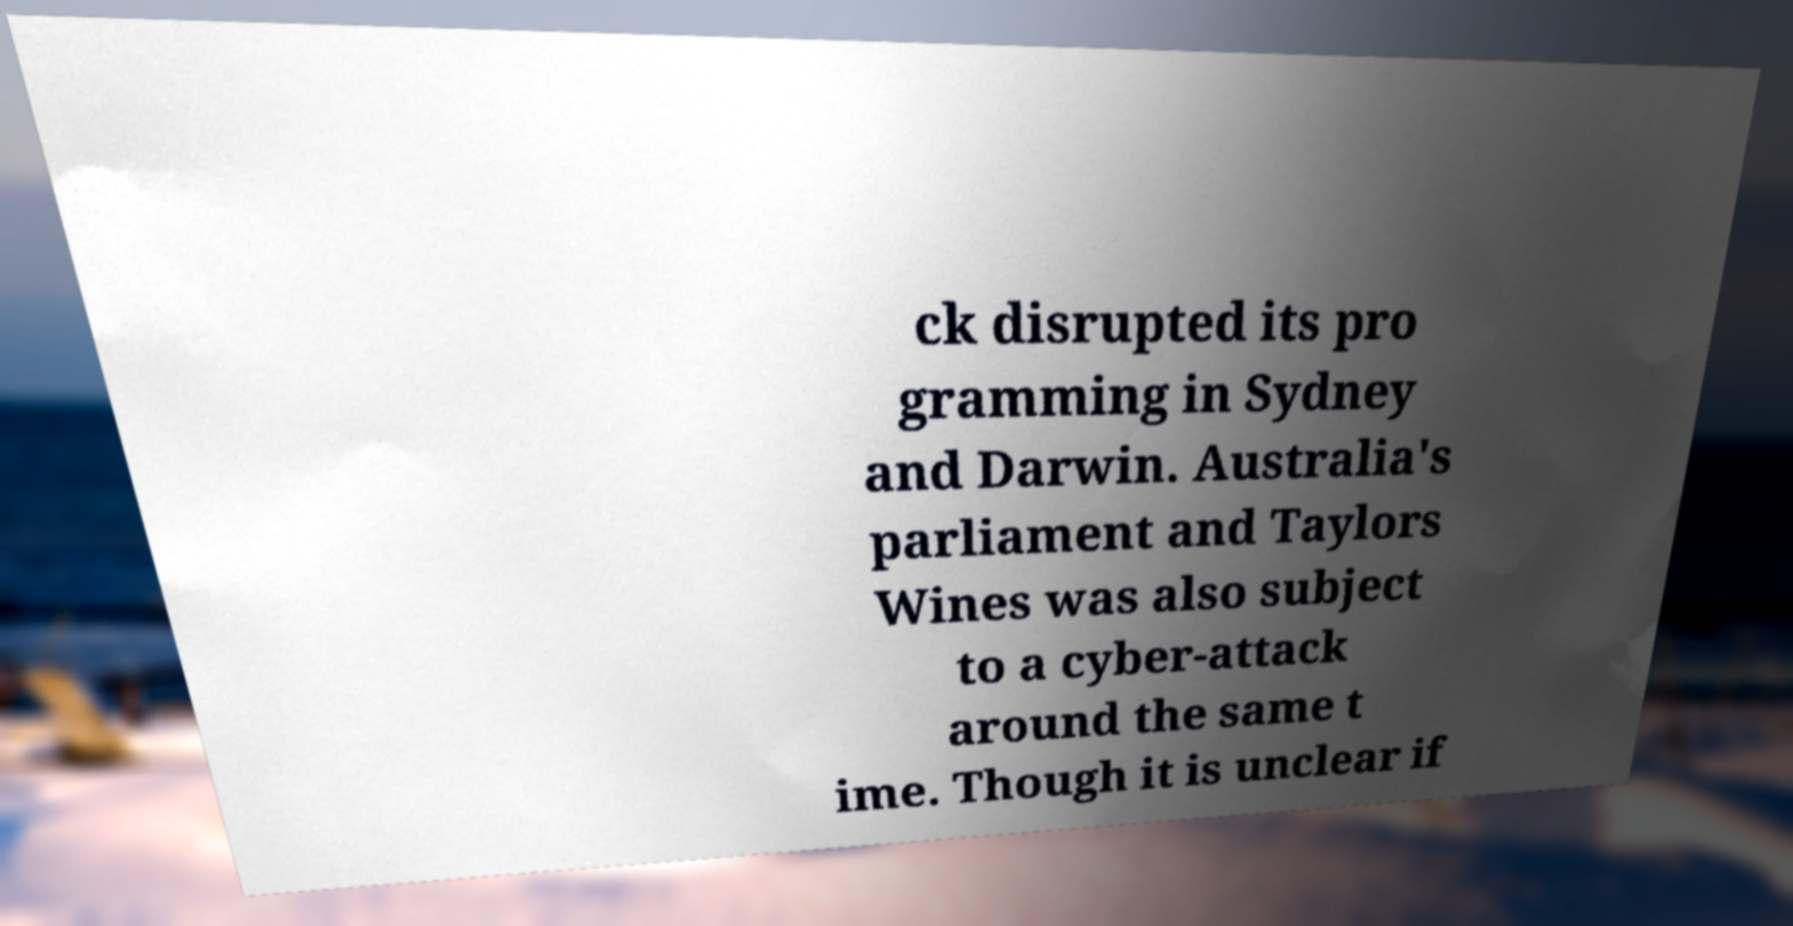For documentation purposes, I need the text within this image transcribed. Could you provide that? ck disrupted its pro gramming in Sydney and Darwin. Australia's parliament and Taylors Wines was also subject to a cyber-attack around the same t ime. Though it is unclear if 